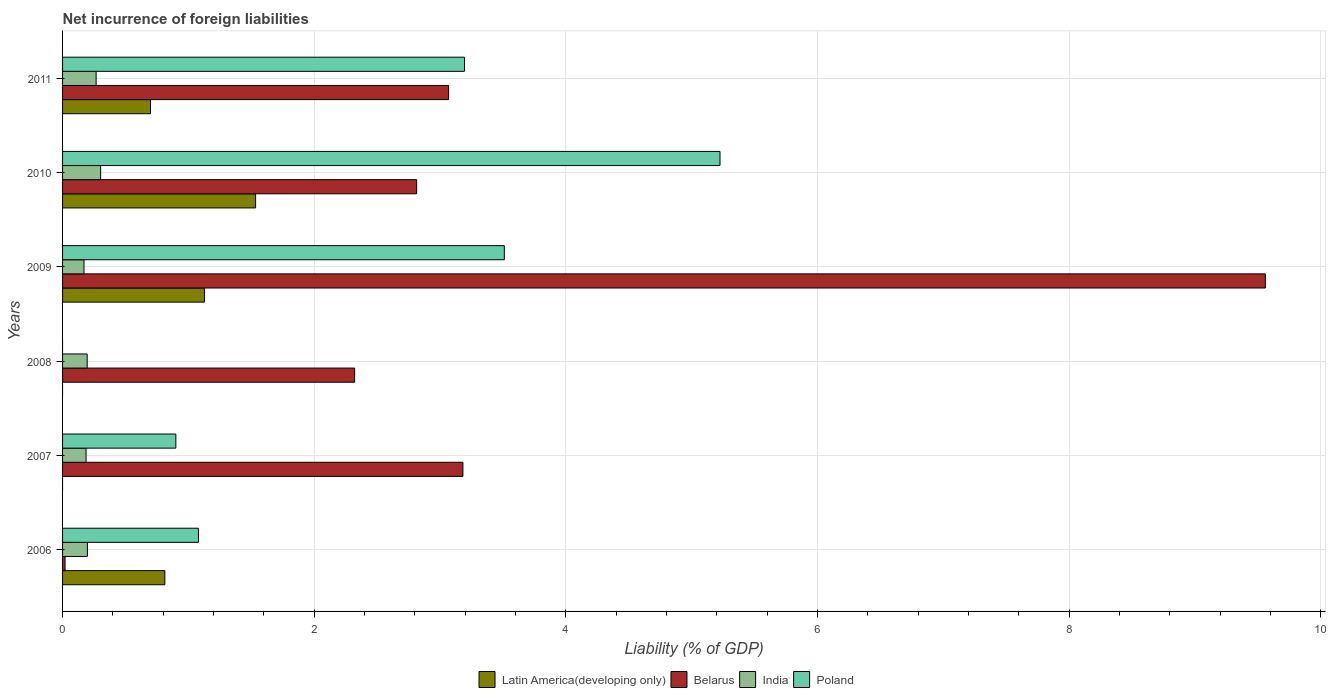Are the number of bars per tick equal to the number of legend labels?
Offer a terse response. No. Are the number of bars on each tick of the Y-axis equal?
Your answer should be very brief. No. What is the net incurrence of foreign liabilities in India in 2008?
Keep it short and to the point. 0.2. Across all years, what is the maximum net incurrence of foreign liabilities in India?
Give a very brief answer. 0.3. Across all years, what is the minimum net incurrence of foreign liabilities in India?
Give a very brief answer. 0.17. What is the total net incurrence of foreign liabilities in Latin America(developing only) in the graph?
Your response must be concise. 4.17. What is the difference between the net incurrence of foreign liabilities in India in 2006 and that in 2009?
Ensure brevity in your answer.  0.03. What is the difference between the net incurrence of foreign liabilities in India in 2010 and the net incurrence of foreign liabilities in Latin America(developing only) in 2011?
Give a very brief answer. -0.4. What is the average net incurrence of foreign liabilities in Poland per year?
Give a very brief answer. 2.32. In the year 2010, what is the difference between the net incurrence of foreign liabilities in India and net incurrence of foreign liabilities in Belarus?
Your response must be concise. -2.51. In how many years, is the net incurrence of foreign liabilities in India greater than 2 %?
Make the answer very short. 0. What is the ratio of the net incurrence of foreign liabilities in India in 2006 to that in 2007?
Keep it short and to the point. 1.06. Is the net incurrence of foreign liabilities in Belarus in 2010 less than that in 2011?
Your response must be concise. Yes. What is the difference between the highest and the second highest net incurrence of foreign liabilities in India?
Make the answer very short. 0.04. What is the difference between the highest and the lowest net incurrence of foreign liabilities in India?
Offer a very short reply. 0.13. In how many years, is the net incurrence of foreign liabilities in Poland greater than the average net incurrence of foreign liabilities in Poland taken over all years?
Provide a succinct answer. 3. Is it the case that in every year, the sum of the net incurrence of foreign liabilities in Belarus and net incurrence of foreign liabilities in Poland is greater than the sum of net incurrence of foreign liabilities in Latin America(developing only) and net incurrence of foreign liabilities in India?
Offer a very short reply. No. Are the values on the major ticks of X-axis written in scientific E-notation?
Ensure brevity in your answer.  No. Does the graph contain grids?
Provide a succinct answer. Yes. How many legend labels are there?
Your answer should be compact. 4. How are the legend labels stacked?
Offer a very short reply. Horizontal. What is the title of the graph?
Provide a short and direct response. Net incurrence of foreign liabilities. What is the label or title of the X-axis?
Your answer should be compact. Liability (% of GDP). What is the label or title of the Y-axis?
Provide a short and direct response. Years. What is the Liability (% of GDP) in Latin America(developing only) in 2006?
Provide a short and direct response. 0.81. What is the Liability (% of GDP) in Belarus in 2006?
Offer a very short reply. 0.02. What is the Liability (% of GDP) in India in 2006?
Your response must be concise. 0.2. What is the Liability (% of GDP) in Poland in 2006?
Give a very brief answer. 1.08. What is the Liability (% of GDP) of Latin America(developing only) in 2007?
Your answer should be compact. 0. What is the Liability (% of GDP) in Belarus in 2007?
Make the answer very short. 3.18. What is the Liability (% of GDP) of India in 2007?
Provide a succinct answer. 0.19. What is the Liability (% of GDP) of Poland in 2007?
Ensure brevity in your answer.  0.9. What is the Liability (% of GDP) in Belarus in 2008?
Keep it short and to the point. 2.32. What is the Liability (% of GDP) of India in 2008?
Ensure brevity in your answer.  0.2. What is the Liability (% of GDP) in Latin America(developing only) in 2009?
Keep it short and to the point. 1.13. What is the Liability (% of GDP) in Belarus in 2009?
Offer a terse response. 9.56. What is the Liability (% of GDP) in India in 2009?
Your response must be concise. 0.17. What is the Liability (% of GDP) in Poland in 2009?
Make the answer very short. 3.51. What is the Liability (% of GDP) in Latin America(developing only) in 2010?
Your answer should be very brief. 1.53. What is the Liability (% of GDP) of Belarus in 2010?
Offer a terse response. 2.81. What is the Liability (% of GDP) of India in 2010?
Offer a terse response. 0.3. What is the Liability (% of GDP) in Poland in 2010?
Keep it short and to the point. 5.22. What is the Liability (% of GDP) of Latin America(developing only) in 2011?
Your response must be concise. 0.7. What is the Liability (% of GDP) of Belarus in 2011?
Offer a terse response. 3.07. What is the Liability (% of GDP) in India in 2011?
Offer a terse response. 0.27. What is the Liability (% of GDP) of Poland in 2011?
Ensure brevity in your answer.  3.19. Across all years, what is the maximum Liability (% of GDP) in Latin America(developing only)?
Your answer should be compact. 1.53. Across all years, what is the maximum Liability (% of GDP) of Belarus?
Offer a very short reply. 9.56. Across all years, what is the maximum Liability (% of GDP) of India?
Provide a short and direct response. 0.3. Across all years, what is the maximum Liability (% of GDP) in Poland?
Give a very brief answer. 5.22. Across all years, what is the minimum Liability (% of GDP) in Belarus?
Make the answer very short. 0.02. Across all years, what is the minimum Liability (% of GDP) of India?
Ensure brevity in your answer.  0.17. Across all years, what is the minimum Liability (% of GDP) of Poland?
Offer a very short reply. 0. What is the total Liability (% of GDP) in Latin America(developing only) in the graph?
Make the answer very short. 4.17. What is the total Liability (% of GDP) of Belarus in the graph?
Give a very brief answer. 20.96. What is the total Liability (% of GDP) in India in the graph?
Your response must be concise. 1.32. What is the total Liability (% of GDP) in Poland in the graph?
Give a very brief answer. 13.91. What is the difference between the Liability (% of GDP) of Belarus in 2006 and that in 2007?
Your response must be concise. -3.16. What is the difference between the Liability (% of GDP) of India in 2006 and that in 2007?
Provide a succinct answer. 0.01. What is the difference between the Liability (% of GDP) in Poland in 2006 and that in 2007?
Provide a succinct answer. 0.18. What is the difference between the Liability (% of GDP) in Belarus in 2006 and that in 2008?
Provide a short and direct response. -2.3. What is the difference between the Liability (% of GDP) in India in 2006 and that in 2008?
Make the answer very short. 0. What is the difference between the Liability (% of GDP) in Latin America(developing only) in 2006 and that in 2009?
Your answer should be compact. -0.32. What is the difference between the Liability (% of GDP) of Belarus in 2006 and that in 2009?
Provide a short and direct response. -9.54. What is the difference between the Liability (% of GDP) of India in 2006 and that in 2009?
Your response must be concise. 0.03. What is the difference between the Liability (% of GDP) in Poland in 2006 and that in 2009?
Offer a terse response. -2.43. What is the difference between the Liability (% of GDP) of Latin America(developing only) in 2006 and that in 2010?
Make the answer very short. -0.72. What is the difference between the Liability (% of GDP) in Belarus in 2006 and that in 2010?
Provide a short and direct response. -2.79. What is the difference between the Liability (% of GDP) in India in 2006 and that in 2010?
Your response must be concise. -0.11. What is the difference between the Liability (% of GDP) of Poland in 2006 and that in 2010?
Ensure brevity in your answer.  -4.14. What is the difference between the Liability (% of GDP) of Latin America(developing only) in 2006 and that in 2011?
Give a very brief answer. 0.11. What is the difference between the Liability (% of GDP) in Belarus in 2006 and that in 2011?
Ensure brevity in your answer.  -3.05. What is the difference between the Liability (% of GDP) in India in 2006 and that in 2011?
Offer a terse response. -0.07. What is the difference between the Liability (% of GDP) of Poland in 2006 and that in 2011?
Make the answer very short. -2.11. What is the difference between the Liability (% of GDP) of Belarus in 2007 and that in 2008?
Keep it short and to the point. 0.86. What is the difference between the Liability (% of GDP) of India in 2007 and that in 2008?
Ensure brevity in your answer.  -0.01. What is the difference between the Liability (% of GDP) of Belarus in 2007 and that in 2009?
Provide a succinct answer. -6.38. What is the difference between the Liability (% of GDP) in India in 2007 and that in 2009?
Provide a short and direct response. 0.02. What is the difference between the Liability (% of GDP) of Poland in 2007 and that in 2009?
Your answer should be compact. -2.61. What is the difference between the Liability (% of GDP) of Belarus in 2007 and that in 2010?
Provide a short and direct response. 0.37. What is the difference between the Liability (% of GDP) in India in 2007 and that in 2010?
Your answer should be very brief. -0.12. What is the difference between the Liability (% of GDP) of Poland in 2007 and that in 2010?
Your answer should be compact. -4.32. What is the difference between the Liability (% of GDP) of Belarus in 2007 and that in 2011?
Offer a terse response. 0.11. What is the difference between the Liability (% of GDP) in India in 2007 and that in 2011?
Offer a very short reply. -0.08. What is the difference between the Liability (% of GDP) of Poland in 2007 and that in 2011?
Give a very brief answer. -2.29. What is the difference between the Liability (% of GDP) in Belarus in 2008 and that in 2009?
Make the answer very short. -7.24. What is the difference between the Liability (% of GDP) in India in 2008 and that in 2009?
Your answer should be compact. 0.03. What is the difference between the Liability (% of GDP) of Belarus in 2008 and that in 2010?
Make the answer very short. -0.49. What is the difference between the Liability (% of GDP) in India in 2008 and that in 2010?
Ensure brevity in your answer.  -0.11. What is the difference between the Liability (% of GDP) in Belarus in 2008 and that in 2011?
Provide a short and direct response. -0.75. What is the difference between the Liability (% of GDP) of India in 2008 and that in 2011?
Your response must be concise. -0.07. What is the difference between the Liability (% of GDP) of Latin America(developing only) in 2009 and that in 2010?
Offer a very short reply. -0.41. What is the difference between the Liability (% of GDP) of Belarus in 2009 and that in 2010?
Keep it short and to the point. 6.74. What is the difference between the Liability (% of GDP) of India in 2009 and that in 2010?
Your answer should be compact. -0.13. What is the difference between the Liability (% of GDP) in Poland in 2009 and that in 2010?
Ensure brevity in your answer.  -1.71. What is the difference between the Liability (% of GDP) in Latin America(developing only) in 2009 and that in 2011?
Offer a terse response. 0.43. What is the difference between the Liability (% of GDP) in Belarus in 2009 and that in 2011?
Your answer should be compact. 6.49. What is the difference between the Liability (% of GDP) of India in 2009 and that in 2011?
Your answer should be compact. -0.1. What is the difference between the Liability (% of GDP) of Poland in 2009 and that in 2011?
Your answer should be compact. 0.32. What is the difference between the Liability (% of GDP) of Latin America(developing only) in 2010 and that in 2011?
Give a very brief answer. 0.84. What is the difference between the Liability (% of GDP) in Belarus in 2010 and that in 2011?
Ensure brevity in your answer.  -0.25. What is the difference between the Liability (% of GDP) in India in 2010 and that in 2011?
Provide a short and direct response. 0.04. What is the difference between the Liability (% of GDP) of Poland in 2010 and that in 2011?
Keep it short and to the point. 2.03. What is the difference between the Liability (% of GDP) in Latin America(developing only) in 2006 and the Liability (% of GDP) in Belarus in 2007?
Provide a succinct answer. -2.37. What is the difference between the Liability (% of GDP) of Latin America(developing only) in 2006 and the Liability (% of GDP) of India in 2007?
Offer a very short reply. 0.63. What is the difference between the Liability (% of GDP) in Latin America(developing only) in 2006 and the Liability (% of GDP) in Poland in 2007?
Provide a succinct answer. -0.09. What is the difference between the Liability (% of GDP) in Belarus in 2006 and the Liability (% of GDP) in India in 2007?
Provide a short and direct response. -0.17. What is the difference between the Liability (% of GDP) of Belarus in 2006 and the Liability (% of GDP) of Poland in 2007?
Your answer should be very brief. -0.88. What is the difference between the Liability (% of GDP) in India in 2006 and the Liability (% of GDP) in Poland in 2007?
Ensure brevity in your answer.  -0.7. What is the difference between the Liability (% of GDP) of Latin America(developing only) in 2006 and the Liability (% of GDP) of Belarus in 2008?
Make the answer very short. -1.51. What is the difference between the Liability (% of GDP) in Latin America(developing only) in 2006 and the Liability (% of GDP) in India in 2008?
Provide a succinct answer. 0.62. What is the difference between the Liability (% of GDP) of Belarus in 2006 and the Liability (% of GDP) of India in 2008?
Your answer should be compact. -0.18. What is the difference between the Liability (% of GDP) in Latin America(developing only) in 2006 and the Liability (% of GDP) in Belarus in 2009?
Give a very brief answer. -8.75. What is the difference between the Liability (% of GDP) of Latin America(developing only) in 2006 and the Liability (% of GDP) of India in 2009?
Make the answer very short. 0.64. What is the difference between the Liability (% of GDP) in Latin America(developing only) in 2006 and the Liability (% of GDP) in Poland in 2009?
Provide a succinct answer. -2.7. What is the difference between the Liability (% of GDP) in Belarus in 2006 and the Liability (% of GDP) in India in 2009?
Offer a very short reply. -0.15. What is the difference between the Liability (% of GDP) in Belarus in 2006 and the Liability (% of GDP) in Poland in 2009?
Offer a terse response. -3.49. What is the difference between the Liability (% of GDP) in India in 2006 and the Liability (% of GDP) in Poland in 2009?
Provide a succinct answer. -3.31. What is the difference between the Liability (% of GDP) of Latin America(developing only) in 2006 and the Liability (% of GDP) of Belarus in 2010?
Keep it short and to the point. -2. What is the difference between the Liability (% of GDP) of Latin America(developing only) in 2006 and the Liability (% of GDP) of India in 2010?
Your answer should be very brief. 0.51. What is the difference between the Liability (% of GDP) in Latin America(developing only) in 2006 and the Liability (% of GDP) in Poland in 2010?
Make the answer very short. -4.41. What is the difference between the Liability (% of GDP) in Belarus in 2006 and the Liability (% of GDP) in India in 2010?
Your answer should be very brief. -0.28. What is the difference between the Liability (% of GDP) of Belarus in 2006 and the Liability (% of GDP) of Poland in 2010?
Provide a succinct answer. -5.2. What is the difference between the Liability (% of GDP) in India in 2006 and the Liability (% of GDP) in Poland in 2010?
Your response must be concise. -5.03. What is the difference between the Liability (% of GDP) in Latin America(developing only) in 2006 and the Liability (% of GDP) in Belarus in 2011?
Give a very brief answer. -2.26. What is the difference between the Liability (% of GDP) of Latin America(developing only) in 2006 and the Liability (% of GDP) of India in 2011?
Provide a short and direct response. 0.55. What is the difference between the Liability (% of GDP) in Latin America(developing only) in 2006 and the Liability (% of GDP) in Poland in 2011?
Make the answer very short. -2.38. What is the difference between the Liability (% of GDP) of Belarus in 2006 and the Liability (% of GDP) of India in 2011?
Your answer should be very brief. -0.25. What is the difference between the Liability (% of GDP) in Belarus in 2006 and the Liability (% of GDP) in Poland in 2011?
Your answer should be compact. -3.17. What is the difference between the Liability (% of GDP) of India in 2006 and the Liability (% of GDP) of Poland in 2011?
Ensure brevity in your answer.  -3. What is the difference between the Liability (% of GDP) of Belarus in 2007 and the Liability (% of GDP) of India in 2008?
Provide a succinct answer. 2.99. What is the difference between the Liability (% of GDP) in Belarus in 2007 and the Liability (% of GDP) in India in 2009?
Ensure brevity in your answer.  3.01. What is the difference between the Liability (% of GDP) in Belarus in 2007 and the Liability (% of GDP) in Poland in 2009?
Provide a short and direct response. -0.33. What is the difference between the Liability (% of GDP) in India in 2007 and the Liability (% of GDP) in Poland in 2009?
Provide a short and direct response. -3.32. What is the difference between the Liability (% of GDP) in Belarus in 2007 and the Liability (% of GDP) in India in 2010?
Offer a very short reply. 2.88. What is the difference between the Liability (% of GDP) of Belarus in 2007 and the Liability (% of GDP) of Poland in 2010?
Your answer should be very brief. -2.04. What is the difference between the Liability (% of GDP) of India in 2007 and the Liability (% of GDP) of Poland in 2010?
Keep it short and to the point. -5.04. What is the difference between the Liability (% of GDP) of Belarus in 2007 and the Liability (% of GDP) of India in 2011?
Provide a succinct answer. 2.91. What is the difference between the Liability (% of GDP) in Belarus in 2007 and the Liability (% of GDP) in Poland in 2011?
Give a very brief answer. -0.01. What is the difference between the Liability (% of GDP) of India in 2007 and the Liability (% of GDP) of Poland in 2011?
Provide a succinct answer. -3.01. What is the difference between the Liability (% of GDP) in Belarus in 2008 and the Liability (% of GDP) in India in 2009?
Keep it short and to the point. 2.15. What is the difference between the Liability (% of GDP) in Belarus in 2008 and the Liability (% of GDP) in Poland in 2009?
Ensure brevity in your answer.  -1.19. What is the difference between the Liability (% of GDP) in India in 2008 and the Liability (% of GDP) in Poland in 2009?
Keep it short and to the point. -3.32. What is the difference between the Liability (% of GDP) of Belarus in 2008 and the Liability (% of GDP) of India in 2010?
Your response must be concise. 2.02. What is the difference between the Liability (% of GDP) of Belarus in 2008 and the Liability (% of GDP) of Poland in 2010?
Provide a short and direct response. -2.9. What is the difference between the Liability (% of GDP) of India in 2008 and the Liability (% of GDP) of Poland in 2010?
Your response must be concise. -5.03. What is the difference between the Liability (% of GDP) in Belarus in 2008 and the Liability (% of GDP) in India in 2011?
Make the answer very short. 2.05. What is the difference between the Liability (% of GDP) of Belarus in 2008 and the Liability (% of GDP) of Poland in 2011?
Provide a succinct answer. -0.87. What is the difference between the Liability (% of GDP) in India in 2008 and the Liability (% of GDP) in Poland in 2011?
Your response must be concise. -3. What is the difference between the Liability (% of GDP) in Latin America(developing only) in 2009 and the Liability (% of GDP) in Belarus in 2010?
Offer a terse response. -1.69. What is the difference between the Liability (% of GDP) of Latin America(developing only) in 2009 and the Liability (% of GDP) of India in 2010?
Offer a terse response. 0.83. What is the difference between the Liability (% of GDP) of Latin America(developing only) in 2009 and the Liability (% of GDP) of Poland in 2010?
Your answer should be compact. -4.1. What is the difference between the Liability (% of GDP) of Belarus in 2009 and the Liability (% of GDP) of India in 2010?
Keep it short and to the point. 9.26. What is the difference between the Liability (% of GDP) in Belarus in 2009 and the Liability (% of GDP) in Poland in 2010?
Ensure brevity in your answer.  4.33. What is the difference between the Liability (% of GDP) in India in 2009 and the Liability (% of GDP) in Poland in 2010?
Keep it short and to the point. -5.05. What is the difference between the Liability (% of GDP) of Latin America(developing only) in 2009 and the Liability (% of GDP) of Belarus in 2011?
Provide a short and direct response. -1.94. What is the difference between the Liability (% of GDP) in Latin America(developing only) in 2009 and the Liability (% of GDP) in India in 2011?
Keep it short and to the point. 0.86. What is the difference between the Liability (% of GDP) in Latin America(developing only) in 2009 and the Liability (% of GDP) in Poland in 2011?
Give a very brief answer. -2.07. What is the difference between the Liability (% of GDP) in Belarus in 2009 and the Liability (% of GDP) in India in 2011?
Keep it short and to the point. 9.29. What is the difference between the Liability (% of GDP) of Belarus in 2009 and the Liability (% of GDP) of Poland in 2011?
Keep it short and to the point. 6.36. What is the difference between the Liability (% of GDP) in India in 2009 and the Liability (% of GDP) in Poland in 2011?
Keep it short and to the point. -3.02. What is the difference between the Liability (% of GDP) in Latin America(developing only) in 2010 and the Liability (% of GDP) in Belarus in 2011?
Make the answer very short. -1.53. What is the difference between the Liability (% of GDP) of Latin America(developing only) in 2010 and the Liability (% of GDP) of India in 2011?
Provide a short and direct response. 1.27. What is the difference between the Liability (% of GDP) in Latin America(developing only) in 2010 and the Liability (% of GDP) in Poland in 2011?
Make the answer very short. -1.66. What is the difference between the Liability (% of GDP) in Belarus in 2010 and the Liability (% of GDP) in India in 2011?
Your answer should be compact. 2.55. What is the difference between the Liability (% of GDP) in Belarus in 2010 and the Liability (% of GDP) in Poland in 2011?
Give a very brief answer. -0.38. What is the difference between the Liability (% of GDP) of India in 2010 and the Liability (% of GDP) of Poland in 2011?
Offer a terse response. -2.89. What is the average Liability (% of GDP) in Latin America(developing only) per year?
Make the answer very short. 0.7. What is the average Liability (% of GDP) in Belarus per year?
Offer a very short reply. 3.49. What is the average Liability (% of GDP) in India per year?
Offer a terse response. 0.22. What is the average Liability (% of GDP) of Poland per year?
Offer a terse response. 2.32. In the year 2006, what is the difference between the Liability (% of GDP) in Latin America(developing only) and Liability (% of GDP) in Belarus?
Your answer should be very brief. 0.79. In the year 2006, what is the difference between the Liability (% of GDP) of Latin America(developing only) and Liability (% of GDP) of India?
Provide a succinct answer. 0.62. In the year 2006, what is the difference between the Liability (% of GDP) in Latin America(developing only) and Liability (% of GDP) in Poland?
Offer a very short reply. -0.27. In the year 2006, what is the difference between the Liability (% of GDP) in Belarus and Liability (% of GDP) in India?
Offer a terse response. -0.18. In the year 2006, what is the difference between the Liability (% of GDP) of Belarus and Liability (% of GDP) of Poland?
Offer a very short reply. -1.06. In the year 2006, what is the difference between the Liability (% of GDP) in India and Liability (% of GDP) in Poland?
Make the answer very short. -0.88. In the year 2007, what is the difference between the Liability (% of GDP) of Belarus and Liability (% of GDP) of India?
Provide a succinct answer. 2.99. In the year 2007, what is the difference between the Liability (% of GDP) of Belarus and Liability (% of GDP) of Poland?
Give a very brief answer. 2.28. In the year 2007, what is the difference between the Liability (% of GDP) of India and Liability (% of GDP) of Poland?
Offer a very short reply. -0.71. In the year 2008, what is the difference between the Liability (% of GDP) in Belarus and Liability (% of GDP) in India?
Offer a terse response. 2.13. In the year 2009, what is the difference between the Liability (% of GDP) of Latin America(developing only) and Liability (% of GDP) of Belarus?
Offer a terse response. -8.43. In the year 2009, what is the difference between the Liability (% of GDP) of Latin America(developing only) and Liability (% of GDP) of India?
Provide a succinct answer. 0.96. In the year 2009, what is the difference between the Liability (% of GDP) in Latin America(developing only) and Liability (% of GDP) in Poland?
Provide a short and direct response. -2.38. In the year 2009, what is the difference between the Liability (% of GDP) in Belarus and Liability (% of GDP) in India?
Provide a short and direct response. 9.39. In the year 2009, what is the difference between the Liability (% of GDP) of Belarus and Liability (% of GDP) of Poland?
Provide a succinct answer. 6.05. In the year 2009, what is the difference between the Liability (% of GDP) in India and Liability (% of GDP) in Poland?
Your answer should be compact. -3.34. In the year 2010, what is the difference between the Liability (% of GDP) of Latin America(developing only) and Liability (% of GDP) of Belarus?
Your answer should be very brief. -1.28. In the year 2010, what is the difference between the Liability (% of GDP) in Latin America(developing only) and Liability (% of GDP) in India?
Offer a very short reply. 1.23. In the year 2010, what is the difference between the Liability (% of GDP) of Latin America(developing only) and Liability (% of GDP) of Poland?
Ensure brevity in your answer.  -3.69. In the year 2010, what is the difference between the Liability (% of GDP) in Belarus and Liability (% of GDP) in India?
Keep it short and to the point. 2.51. In the year 2010, what is the difference between the Liability (% of GDP) of Belarus and Liability (% of GDP) of Poland?
Your answer should be compact. -2.41. In the year 2010, what is the difference between the Liability (% of GDP) of India and Liability (% of GDP) of Poland?
Give a very brief answer. -4.92. In the year 2011, what is the difference between the Liability (% of GDP) of Latin America(developing only) and Liability (% of GDP) of Belarus?
Give a very brief answer. -2.37. In the year 2011, what is the difference between the Liability (% of GDP) in Latin America(developing only) and Liability (% of GDP) in India?
Make the answer very short. 0.43. In the year 2011, what is the difference between the Liability (% of GDP) of Latin America(developing only) and Liability (% of GDP) of Poland?
Give a very brief answer. -2.5. In the year 2011, what is the difference between the Liability (% of GDP) of Belarus and Liability (% of GDP) of India?
Ensure brevity in your answer.  2.8. In the year 2011, what is the difference between the Liability (% of GDP) of Belarus and Liability (% of GDP) of Poland?
Your answer should be very brief. -0.13. In the year 2011, what is the difference between the Liability (% of GDP) in India and Liability (% of GDP) in Poland?
Ensure brevity in your answer.  -2.93. What is the ratio of the Liability (% of GDP) of Belarus in 2006 to that in 2007?
Offer a terse response. 0.01. What is the ratio of the Liability (% of GDP) in India in 2006 to that in 2007?
Your answer should be compact. 1.06. What is the ratio of the Liability (% of GDP) of Poland in 2006 to that in 2007?
Offer a very short reply. 1.2. What is the ratio of the Liability (% of GDP) of Belarus in 2006 to that in 2008?
Provide a succinct answer. 0.01. What is the ratio of the Liability (% of GDP) of India in 2006 to that in 2008?
Give a very brief answer. 1.01. What is the ratio of the Liability (% of GDP) of Latin America(developing only) in 2006 to that in 2009?
Offer a very short reply. 0.72. What is the ratio of the Liability (% of GDP) in Belarus in 2006 to that in 2009?
Give a very brief answer. 0. What is the ratio of the Liability (% of GDP) in India in 2006 to that in 2009?
Ensure brevity in your answer.  1.16. What is the ratio of the Liability (% of GDP) of Poland in 2006 to that in 2009?
Keep it short and to the point. 0.31. What is the ratio of the Liability (% of GDP) of Latin America(developing only) in 2006 to that in 2010?
Offer a terse response. 0.53. What is the ratio of the Liability (% of GDP) in Belarus in 2006 to that in 2010?
Make the answer very short. 0.01. What is the ratio of the Liability (% of GDP) in India in 2006 to that in 2010?
Keep it short and to the point. 0.65. What is the ratio of the Liability (% of GDP) in Poland in 2006 to that in 2010?
Provide a succinct answer. 0.21. What is the ratio of the Liability (% of GDP) in Latin America(developing only) in 2006 to that in 2011?
Give a very brief answer. 1.16. What is the ratio of the Liability (% of GDP) of Belarus in 2006 to that in 2011?
Your answer should be very brief. 0.01. What is the ratio of the Liability (% of GDP) of India in 2006 to that in 2011?
Provide a short and direct response. 0.74. What is the ratio of the Liability (% of GDP) in Poland in 2006 to that in 2011?
Your answer should be compact. 0.34. What is the ratio of the Liability (% of GDP) in Belarus in 2007 to that in 2008?
Offer a very short reply. 1.37. What is the ratio of the Liability (% of GDP) in India in 2007 to that in 2008?
Provide a short and direct response. 0.95. What is the ratio of the Liability (% of GDP) of Belarus in 2007 to that in 2009?
Your answer should be very brief. 0.33. What is the ratio of the Liability (% of GDP) in India in 2007 to that in 2009?
Your answer should be very brief. 1.1. What is the ratio of the Liability (% of GDP) in Poland in 2007 to that in 2009?
Your answer should be very brief. 0.26. What is the ratio of the Liability (% of GDP) in Belarus in 2007 to that in 2010?
Your response must be concise. 1.13. What is the ratio of the Liability (% of GDP) of India in 2007 to that in 2010?
Give a very brief answer. 0.62. What is the ratio of the Liability (% of GDP) of Poland in 2007 to that in 2010?
Provide a short and direct response. 0.17. What is the ratio of the Liability (% of GDP) in Belarus in 2007 to that in 2011?
Ensure brevity in your answer.  1.04. What is the ratio of the Liability (% of GDP) in India in 2007 to that in 2011?
Your answer should be very brief. 0.7. What is the ratio of the Liability (% of GDP) in Poland in 2007 to that in 2011?
Offer a terse response. 0.28. What is the ratio of the Liability (% of GDP) of Belarus in 2008 to that in 2009?
Offer a terse response. 0.24. What is the ratio of the Liability (% of GDP) of India in 2008 to that in 2009?
Your answer should be compact. 1.15. What is the ratio of the Liability (% of GDP) in Belarus in 2008 to that in 2010?
Ensure brevity in your answer.  0.82. What is the ratio of the Liability (% of GDP) in India in 2008 to that in 2010?
Ensure brevity in your answer.  0.65. What is the ratio of the Liability (% of GDP) of Belarus in 2008 to that in 2011?
Provide a succinct answer. 0.76. What is the ratio of the Liability (% of GDP) of India in 2008 to that in 2011?
Make the answer very short. 0.73. What is the ratio of the Liability (% of GDP) of Latin America(developing only) in 2009 to that in 2010?
Your response must be concise. 0.74. What is the ratio of the Liability (% of GDP) in Belarus in 2009 to that in 2010?
Offer a very short reply. 3.4. What is the ratio of the Liability (% of GDP) of India in 2009 to that in 2010?
Your answer should be compact. 0.56. What is the ratio of the Liability (% of GDP) in Poland in 2009 to that in 2010?
Provide a short and direct response. 0.67. What is the ratio of the Liability (% of GDP) in Latin America(developing only) in 2009 to that in 2011?
Your answer should be very brief. 1.61. What is the ratio of the Liability (% of GDP) of Belarus in 2009 to that in 2011?
Offer a very short reply. 3.12. What is the ratio of the Liability (% of GDP) in India in 2009 to that in 2011?
Provide a succinct answer. 0.64. What is the ratio of the Liability (% of GDP) of Poland in 2009 to that in 2011?
Offer a very short reply. 1.1. What is the ratio of the Liability (% of GDP) in Latin America(developing only) in 2010 to that in 2011?
Ensure brevity in your answer.  2.2. What is the ratio of the Liability (% of GDP) of Belarus in 2010 to that in 2011?
Provide a succinct answer. 0.92. What is the ratio of the Liability (% of GDP) in India in 2010 to that in 2011?
Your response must be concise. 1.13. What is the ratio of the Liability (% of GDP) of Poland in 2010 to that in 2011?
Give a very brief answer. 1.64. What is the difference between the highest and the second highest Liability (% of GDP) in Latin America(developing only)?
Keep it short and to the point. 0.41. What is the difference between the highest and the second highest Liability (% of GDP) in Belarus?
Make the answer very short. 6.38. What is the difference between the highest and the second highest Liability (% of GDP) in India?
Give a very brief answer. 0.04. What is the difference between the highest and the second highest Liability (% of GDP) of Poland?
Your answer should be very brief. 1.71. What is the difference between the highest and the lowest Liability (% of GDP) of Latin America(developing only)?
Offer a terse response. 1.53. What is the difference between the highest and the lowest Liability (% of GDP) of Belarus?
Your answer should be very brief. 9.54. What is the difference between the highest and the lowest Liability (% of GDP) in India?
Your answer should be very brief. 0.13. What is the difference between the highest and the lowest Liability (% of GDP) in Poland?
Provide a succinct answer. 5.22. 